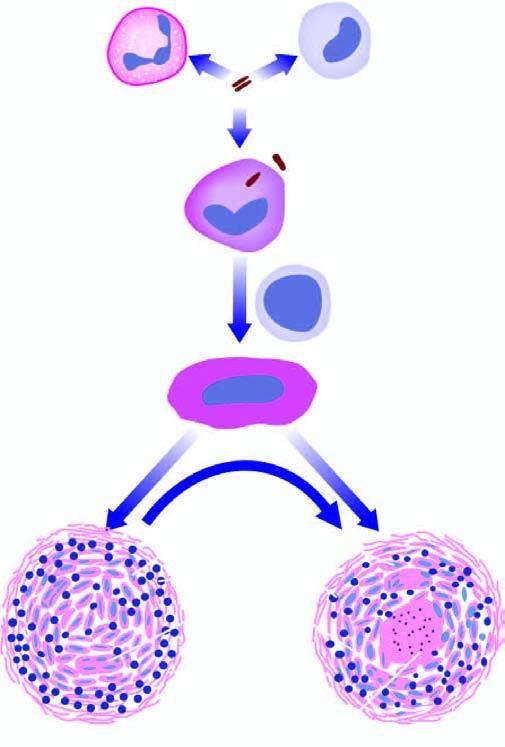s electron microscopy composed of granular caseation necrosis, surrounded by epithelioid cells and langhans ' giant cells and peripheral rim of lymphocytes bounded by fibroblasts in fully formed granuloma?
Answer the question using a single word or phrase. No 